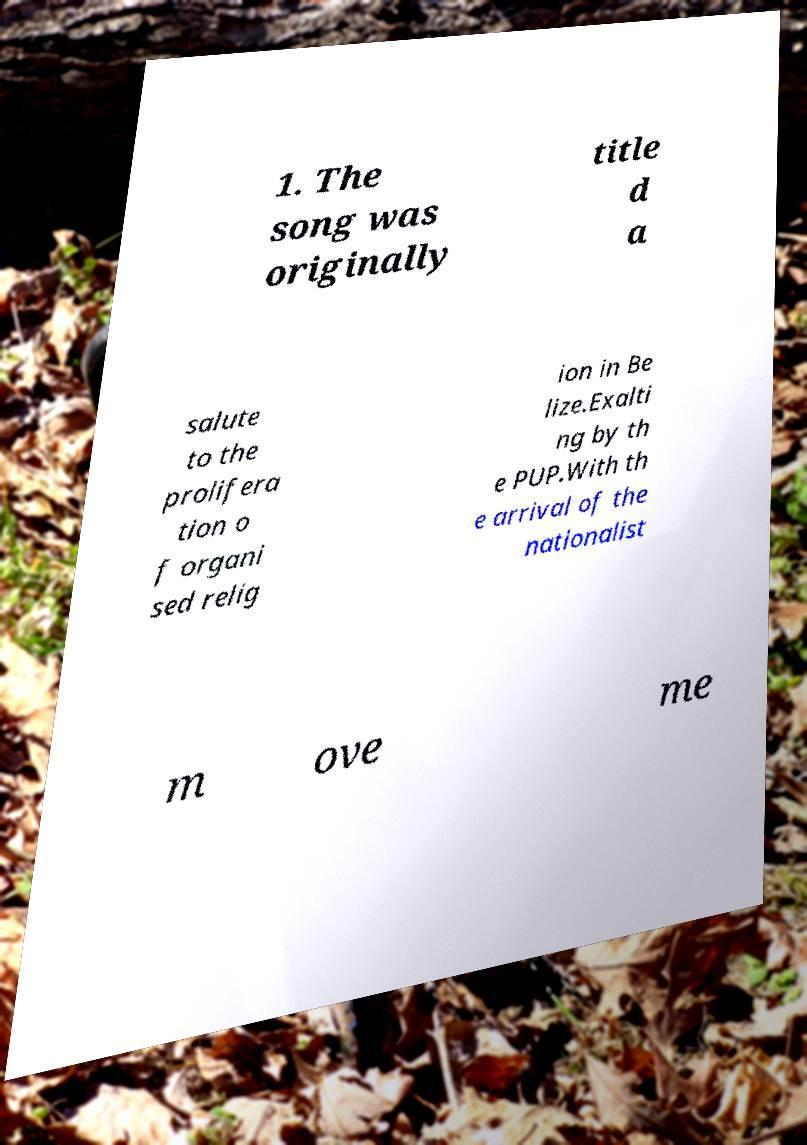What messages or text are displayed in this image? I need them in a readable, typed format. 1. The song was originally title d a salute to the prolifera tion o f organi sed relig ion in Be lize.Exalti ng by th e PUP.With th e arrival of the nationalist m ove me 